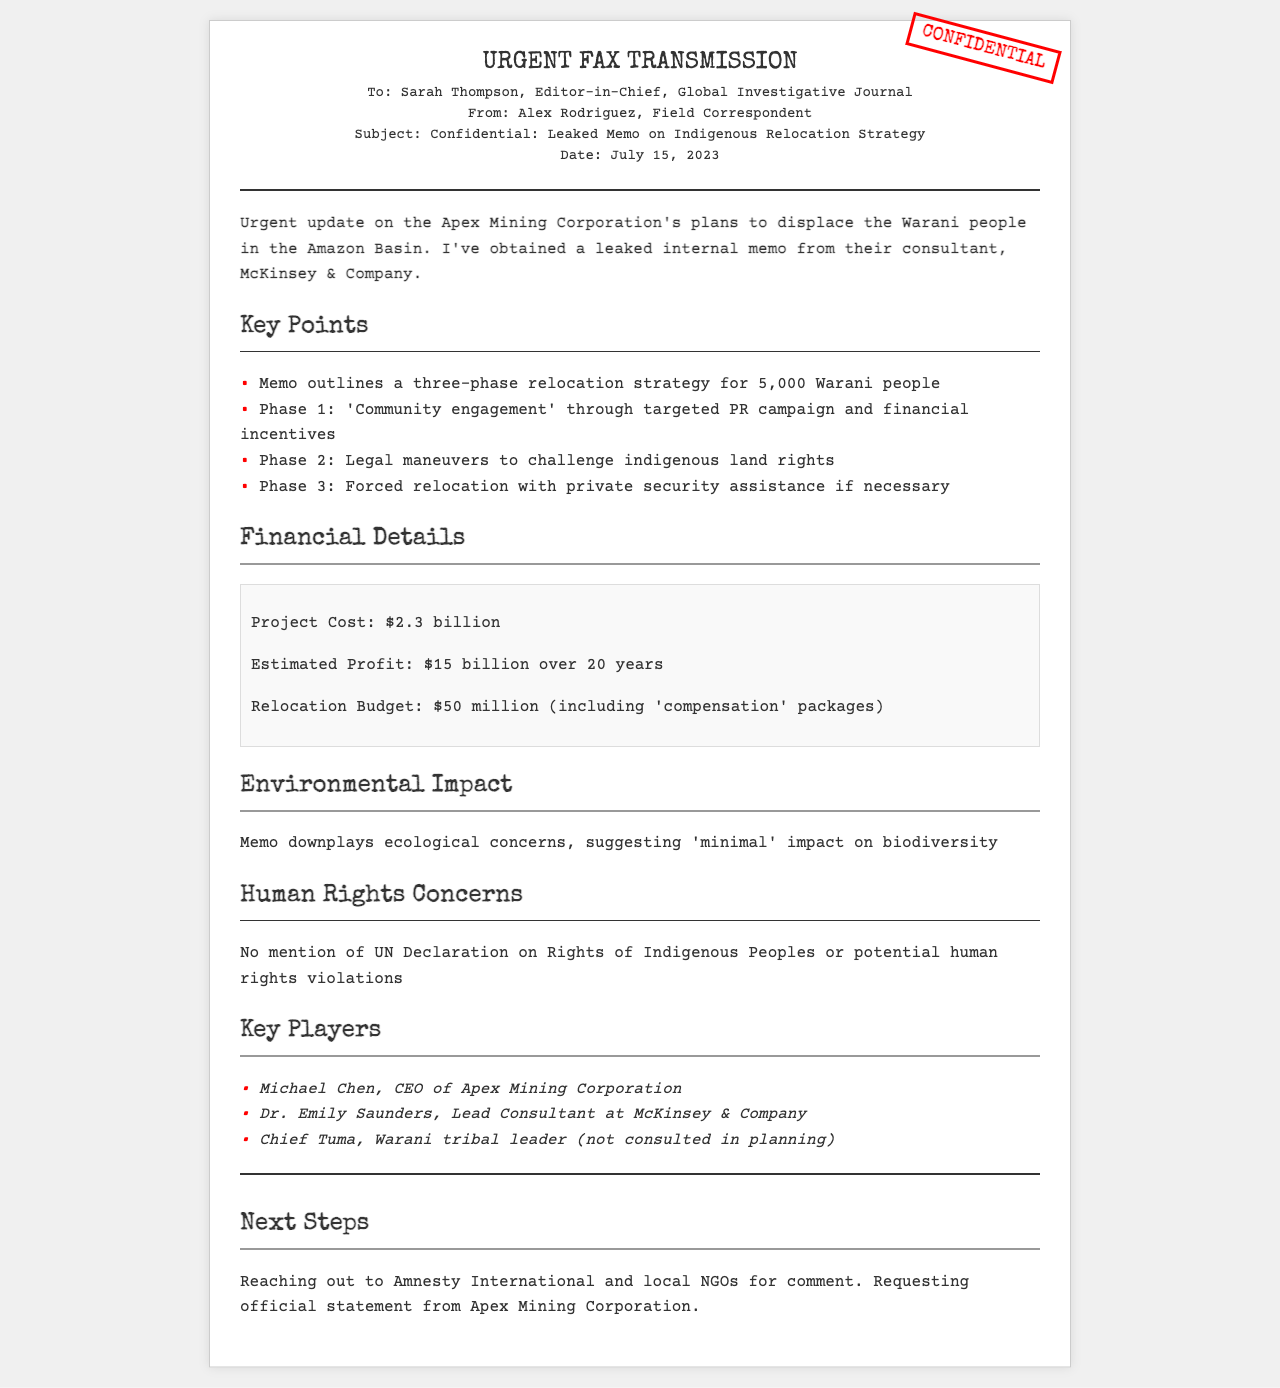what is the project cost? The project cost is explicitly stated in the memo as $2.3 billion.
Answer: $2.3 billion how many Warani people are targeted for relocation? The memo outlines that 5,000 Warani people are being targeted for relocation as per the strategy.
Answer: 5,000 who is the lead consultant at McKinsey & Company? The memo mentions Dr. Emily Saunders as the Lead Consultant at McKinsey & Company.
Answer: Dr. Emily Saunders what is the estimated profit over 20 years? The estimated profit is specified in the memo as $15 billion over 20 years.
Answer: $15 billion what phase involves legal maneuvers against land rights? Phase 2 of the relocation strategy involves legal maneuvers aimed at challenging indigenous land rights.
Answer: Phase 2 what does the memo say about ecological concerns? The memo downplays ecological concerns, suggesting there will be 'minimal' impact on biodiversity.
Answer: 'minimal' how much is allocated for the relocation budget? The relocation budget is clearly stated in the document to be $50 million.
Answer: $50 million who is the CEO of Apex Mining Corporation? The memo identifies Michael Chen as the CEO of Apex Mining Corporation.
Answer: Michael Chen what human rights document is not mentioned in the memo? The memo does not mention the UN Declaration on Rights of Indigenous Peoples.
Answer: UN Declaration on Rights of Indigenous Peoples 